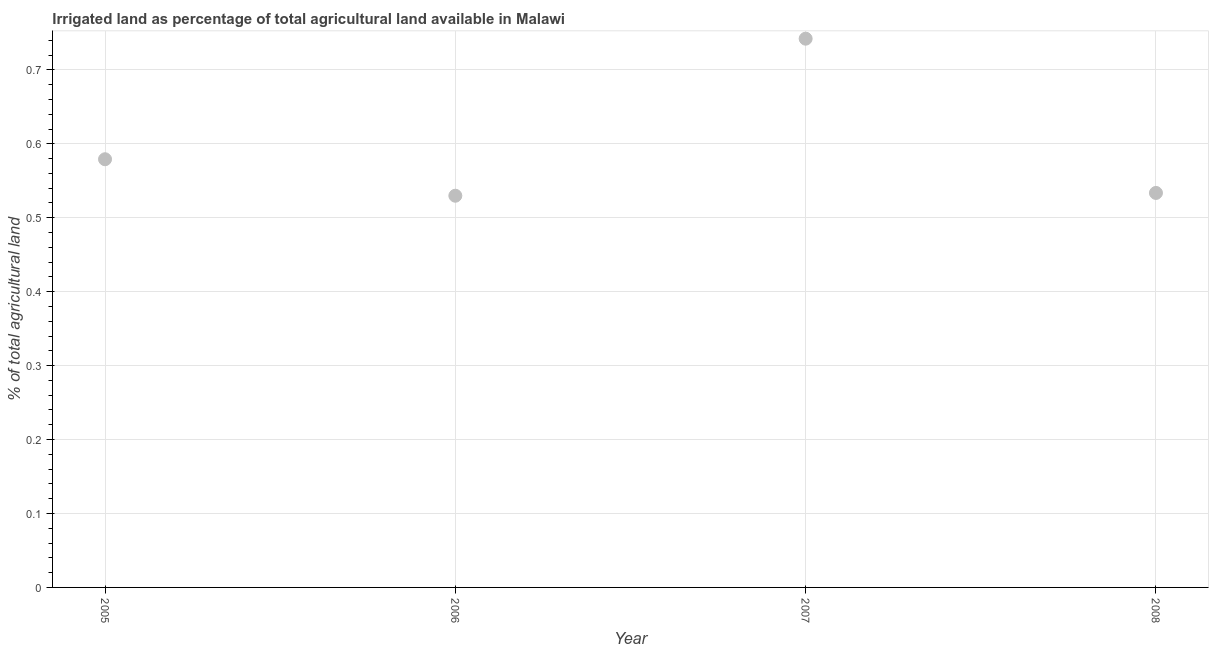What is the percentage of agricultural irrigated land in 2008?
Give a very brief answer. 0.53. Across all years, what is the maximum percentage of agricultural irrigated land?
Your answer should be very brief. 0.74. Across all years, what is the minimum percentage of agricultural irrigated land?
Your response must be concise. 0.53. What is the sum of the percentage of agricultural irrigated land?
Offer a very short reply. 2.38. What is the difference between the percentage of agricultural irrigated land in 2007 and 2008?
Your answer should be compact. 0.21. What is the average percentage of agricultural irrigated land per year?
Ensure brevity in your answer.  0.6. What is the median percentage of agricultural irrigated land?
Offer a terse response. 0.56. In how many years, is the percentage of agricultural irrigated land greater than 0.46 %?
Your answer should be compact. 4. What is the ratio of the percentage of agricultural irrigated land in 2006 to that in 2008?
Offer a terse response. 0.99. What is the difference between the highest and the second highest percentage of agricultural irrigated land?
Keep it short and to the point. 0.16. Is the sum of the percentage of agricultural irrigated land in 2005 and 2007 greater than the maximum percentage of agricultural irrigated land across all years?
Your response must be concise. Yes. What is the difference between the highest and the lowest percentage of agricultural irrigated land?
Offer a very short reply. 0.21. In how many years, is the percentage of agricultural irrigated land greater than the average percentage of agricultural irrigated land taken over all years?
Offer a very short reply. 1. What is the difference between two consecutive major ticks on the Y-axis?
Provide a short and direct response. 0.1. Are the values on the major ticks of Y-axis written in scientific E-notation?
Make the answer very short. No. Does the graph contain grids?
Your response must be concise. Yes. What is the title of the graph?
Keep it short and to the point. Irrigated land as percentage of total agricultural land available in Malawi. What is the label or title of the Y-axis?
Provide a succinct answer. % of total agricultural land. What is the % of total agricultural land in 2005?
Provide a short and direct response. 0.58. What is the % of total agricultural land in 2006?
Keep it short and to the point. 0.53. What is the % of total agricultural land in 2007?
Your answer should be compact. 0.74. What is the % of total agricultural land in 2008?
Ensure brevity in your answer.  0.53. What is the difference between the % of total agricultural land in 2005 and 2006?
Provide a short and direct response. 0.05. What is the difference between the % of total agricultural land in 2005 and 2007?
Keep it short and to the point. -0.16. What is the difference between the % of total agricultural land in 2005 and 2008?
Keep it short and to the point. 0.05. What is the difference between the % of total agricultural land in 2006 and 2007?
Offer a very short reply. -0.21. What is the difference between the % of total agricultural land in 2006 and 2008?
Provide a succinct answer. -0. What is the difference between the % of total agricultural land in 2007 and 2008?
Offer a terse response. 0.21. What is the ratio of the % of total agricultural land in 2005 to that in 2006?
Keep it short and to the point. 1.09. What is the ratio of the % of total agricultural land in 2005 to that in 2007?
Keep it short and to the point. 0.78. What is the ratio of the % of total agricultural land in 2005 to that in 2008?
Your answer should be compact. 1.08. What is the ratio of the % of total agricultural land in 2006 to that in 2007?
Offer a terse response. 0.71. What is the ratio of the % of total agricultural land in 2006 to that in 2008?
Offer a terse response. 0.99. What is the ratio of the % of total agricultural land in 2007 to that in 2008?
Give a very brief answer. 1.39. 